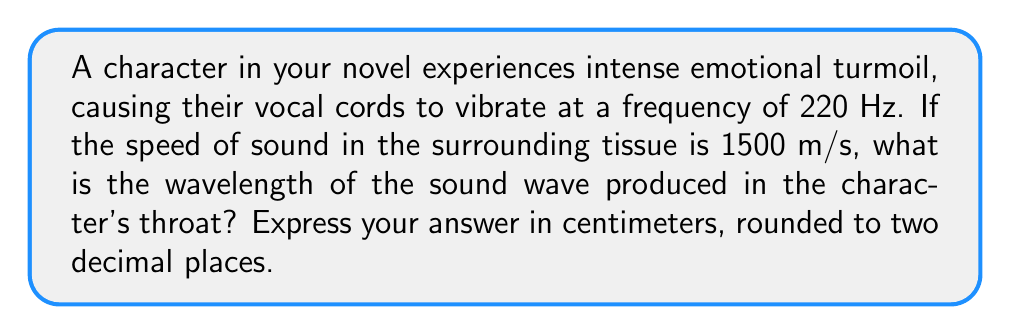Could you help me with this problem? To solve this problem, we'll use the wave equation that relates wave speed, frequency, and wavelength:

$$v = f \lambda$$

Where:
$v$ = wave speed (m/s)
$f$ = frequency (Hz)
$\lambda$ = wavelength (m)

Given:
$v = 1500$ m/s
$f = 220$ Hz

Step 1: Rearrange the equation to solve for wavelength:
$$\lambda = \frac{v}{f}$$

Step 2: Substitute the known values:
$$\lambda = \frac{1500 \text{ m/s}}{220 \text{ Hz}}$$

Step 3: Calculate the wavelength:
$$\lambda = 6.8181... \text{ m}$$

Step 4: Convert the result to centimeters:
$$6.8181... \text{ m} \times 100 \text{ cm/m} = 681.81... \text{ cm}$$

Step 5: Round to two decimal places:
$$681.81... \text{ cm} \approx 681.82 \text{ cm}$$
Answer: 681.82 cm 